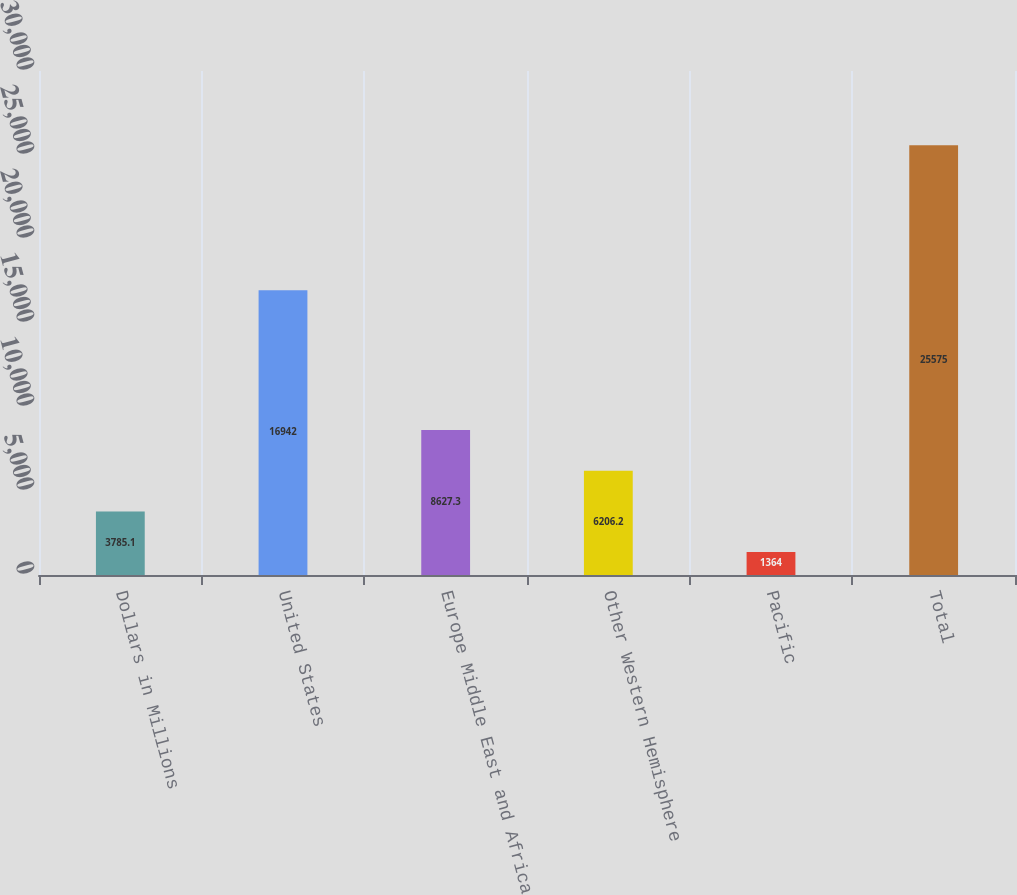Convert chart. <chart><loc_0><loc_0><loc_500><loc_500><bar_chart><fcel>Dollars in Millions<fcel>United States<fcel>Europe Middle East and Africa<fcel>Other Western Hemisphere<fcel>Pacific<fcel>Total<nl><fcel>3785.1<fcel>16942<fcel>8627.3<fcel>6206.2<fcel>1364<fcel>25575<nl></chart> 